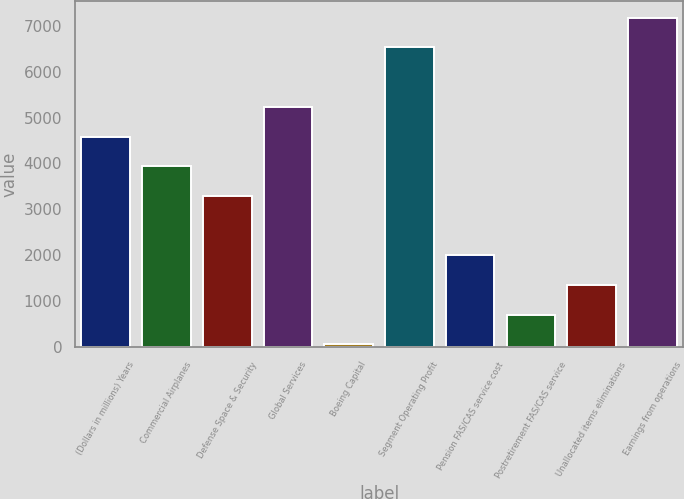Convert chart. <chart><loc_0><loc_0><loc_500><loc_500><bar_chart><fcel>(Dollars in millions) Years<fcel>Commercial Airplanes<fcel>Defense Space & Security<fcel>Global Services<fcel>Boeing Capital<fcel>Segment Operating Profit<fcel>Pension FAS/CAS service cost<fcel>Postretirement FAS/CAS service<fcel>Unallocated items eliminations<fcel>Earnings from operations<nl><fcel>4586.6<fcel>3939.8<fcel>3293<fcel>5233.4<fcel>59<fcel>6527<fcel>1999.4<fcel>705.8<fcel>1352.6<fcel>7173.8<nl></chart> 